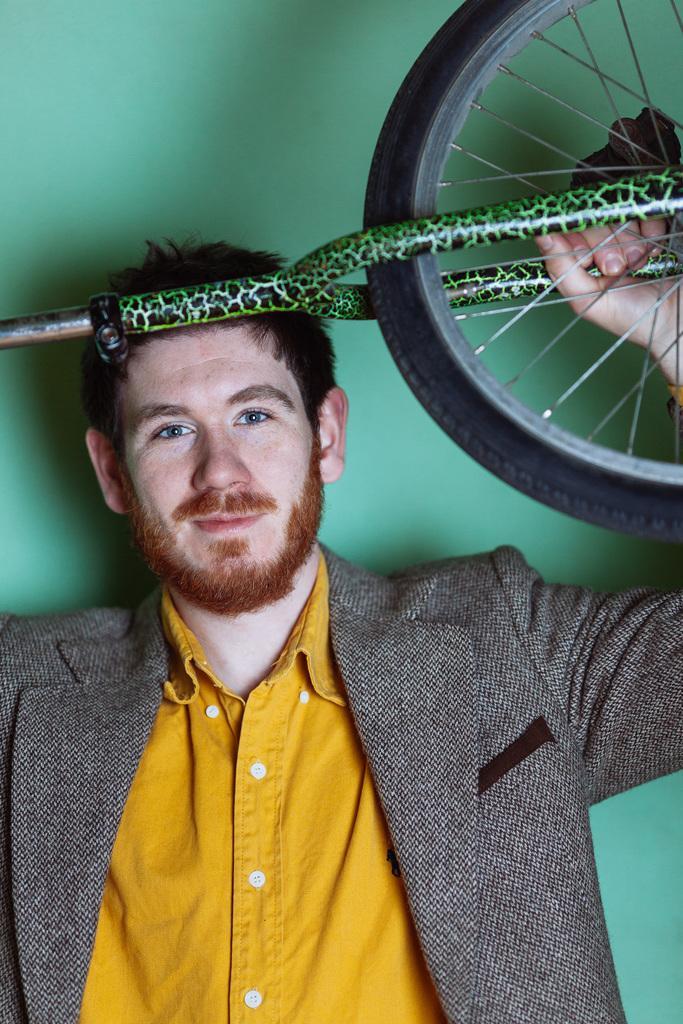Could you give a brief overview of what you see in this image? In this picture there is a man in the center of the image, by holding a bicycle in his hands. 